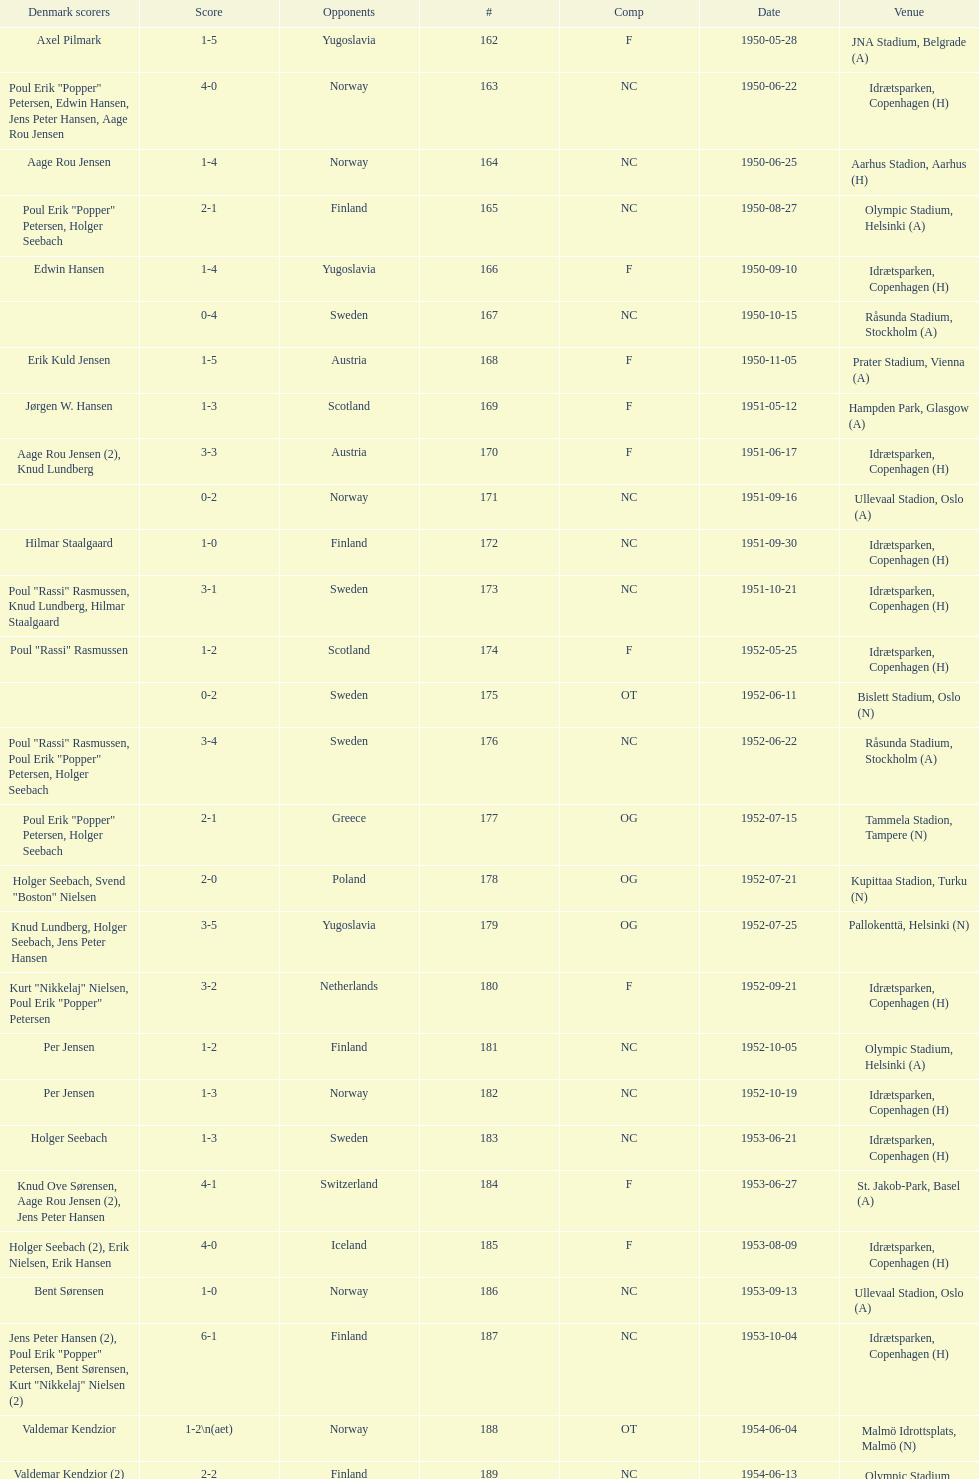Can you identify the venue located immediately below jna stadium, belgrade (a)? Idrætsparken, Copenhagen (H). Would you be able to parse every entry in this table? {'header': ['Denmark scorers', 'Score', 'Opponents', '#', 'Comp', 'Date', 'Venue'], 'rows': [['Axel Pilmark', '1-5', 'Yugoslavia', '162', 'F', '1950-05-28', 'JNA Stadium, Belgrade (A)'], ['Poul Erik "Popper" Petersen, Edwin Hansen, Jens Peter Hansen, Aage Rou Jensen', '4-0', 'Norway', '163', 'NC', '1950-06-22', 'Idrætsparken, Copenhagen (H)'], ['Aage Rou Jensen', '1-4', 'Norway', '164', 'NC', '1950-06-25', 'Aarhus Stadion, Aarhus (H)'], ['Poul Erik "Popper" Petersen, Holger Seebach', '2-1', 'Finland', '165', 'NC', '1950-08-27', 'Olympic Stadium, Helsinki (A)'], ['Edwin Hansen', '1-4', 'Yugoslavia', '166', 'F', '1950-09-10', 'Idrætsparken, Copenhagen (H)'], ['', '0-4', 'Sweden', '167', 'NC', '1950-10-15', 'Råsunda Stadium, Stockholm (A)'], ['Erik Kuld Jensen', '1-5', 'Austria', '168', 'F', '1950-11-05', 'Prater Stadium, Vienna (A)'], ['Jørgen W. Hansen', '1-3', 'Scotland', '169', 'F', '1951-05-12', 'Hampden Park, Glasgow (A)'], ['Aage Rou Jensen (2), Knud Lundberg', '3-3', 'Austria', '170', 'F', '1951-06-17', 'Idrætsparken, Copenhagen (H)'], ['', '0-2', 'Norway', '171', 'NC', '1951-09-16', 'Ullevaal Stadion, Oslo (A)'], ['Hilmar Staalgaard', '1-0', 'Finland', '172', 'NC', '1951-09-30', 'Idrætsparken, Copenhagen (H)'], ['Poul "Rassi" Rasmussen, Knud Lundberg, Hilmar Staalgaard', '3-1', 'Sweden', '173', 'NC', '1951-10-21', 'Idrætsparken, Copenhagen (H)'], ['Poul "Rassi" Rasmussen', '1-2', 'Scotland', '174', 'F', '1952-05-25', 'Idrætsparken, Copenhagen (H)'], ['', '0-2', 'Sweden', '175', 'OT', '1952-06-11', 'Bislett Stadium, Oslo (N)'], ['Poul "Rassi" Rasmussen, Poul Erik "Popper" Petersen, Holger Seebach', '3-4', 'Sweden', '176', 'NC', '1952-06-22', 'Råsunda Stadium, Stockholm (A)'], ['Poul Erik "Popper" Petersen, Holger Seebach', '2-1', 'Greece', '177', 'OG', '1952-07-15', 'Tammela Stadion, Tampere (N)'], ['Holger Seebach, Svend "Boston" Nielsen', '2-0', 'Poland', '178', 'OG', '1952-07-21', 'Kupittaa Stadion, Turku (N)'], ['Knud Lundberg, Holger Seebach, Jens Peter Hansen', '3-5', 'Yugoslavia', '179', 'OG', '1952-07-25', 'Pallokenttä, Helsinki (N)'], ['Kurt "Nikkelaj" Nielsen, Poul Erik "Popper" Petersen', '3-2', 'Netherlands', '180', 'F', '1952-09-21', 'Idrætsparken, Copenhagen (H)'], ['Per Jensen', '1-2', 'Finland', '181', 'NC', '1952-10-05', 'Olympic Stadium, Helsinki (A)'], ['Per Jensen', '1-3', 'Norway', '182', 'NC', '1952-10-19', 'Idrætsparken, Copenhagen (H)'], ['Holger Seebach', '1-3', 'Sweden', '183', 'NC', '1953-06-21', 'Idrætsparken, Copenhagen (H)'], ['Knud Ove Sørensen, Aage Rou Jensen (2), Jens Peter Hansen', '4-1', 'Switzerland', '184', 'F', '1953-06-27', 'St. Jakob-Park, Basel (A)'], ['Holger Seebach (2), Erik Nielsen, Erik Hansen', '4-0', 'Iceland', '185', 'F', '1953-08-09', 'Idrætsparken, Copenhagen (H)'], ['Bent Sørensen', '1-0', 'Norway', '186', 'NC', '1953-09-13', 'Ullevaal Stadion, Oslo (A)'], ['Jens Peter Hansen (2), Poul Erik "Popper" Petersen, Bent Sørensen, Kurt "Nikkelaj" Nielsen (2)', '6-1', 'Finland', '187', 'NC', '1953-10-04', 'Idrætsparken, Copenhagen (H)'], ['Valdemar Kendzior', '1-2\\n(aet)', 'Norway', '188', 'OT', '1954-06-04', 'Malmö Idrottsplats, Malmö (N)'], ['Valdemar Kendzior (2)', '2-2', 'Finland', '189', 'NC', '1954-06-13', 'Olympic Stadium, Helsinki (A)'], ['Jørgen Olesen', '1-1', 'Switzerland', '190', 'F', '1954-09-19', 'Idrætsparken, Copenhagen (H)'], ['Jens Peter Hansen, Bent Sørensen', '2-5', 'Sweden', '191', 'NC', '1954-10-10', 'Råsunda Stadium, Stockholm (A)'], ['', '0-1', 'Norway', '192', 'NC', '1954-10-31', 'Idrætsparken, Copenhagen (H)'], ['Vagn Birkeland', '1-1', 'Netherlands', '193', 'F', '1955-03-13', 'Olympic Stadium, Amsterdam (A)'], ['', '0-6', 'Hungary', '194', 'F', '1955-05-15', 'Idrætsparken, Copenhagen (H)'], ['Jens Peter Hansen (2)', '2-1', 'Finland', '195', 'NC', '1955-06-19', 'Idrætsparken, Copenhagen (H)'], ['Aage Rou Jensen, Jens Peter Hansen, Poul Pedersen (2)', '4-0', 'Iceland', '196', 'F', '1955-06-03', 'Melavollur, Reykjavík (A)'], ['Jørgen Jacobsen', '1-1', 'Norway', '197', 'NC', '1955-09-11', 'Ullevaal Stadion, Oslo (A)'], ['Knud Lundberg', '1-5', 'England', '198', 'NC', '1955-10-02', 'Idrætsparken, Copenhagen (H)'], ['Ove Andersen (2), Knud Lundberg', '3-3', 'Sweden', '199', 'NC', '1955-10-16', 'Idrætsparken, Copenhagen (H)'], ['Knud Lundberg', '1-5', 'USSR', '200', 'F', '1956-05-23', 'Dynamo Stadium, Moscow (A)'], ['Knud Lundberg, Poul Pedersen', '2-3', 'Norway', '201', 'NC', '1956-06-24', 'Idrætsparken, Copenhagen (H)'], ['Ove Andersen, Aage Rou Jensen', '2-5', 'USSR', '202', 'F', '1956-07-01', 'Idrætsparken, Copenhagen (H)'], ['Poul Pedersen, Jørgen Hansen, Ove Andersen (2)', '4-0', 'Finland', '203', 'NC', '1956-09-16', 'Olympic Stadium, Helsinki (A)'], ['Aage Rou Jensen', '1-2', 'Republic of Ireland', '204', 'WCQ', '1956-10-03', 'Dalymount Park, Dublin (A)'], ['Jens Peter Hansen', '1-1', 'Sweden', '205', 'NC', '1956-10-21', 'Råsunda Stadium, Stockholm (A)'], ['Jørgen Olesen, Knud Lundberg', '2-2', 'Netherlands', '206', 'F', '1956-11-04', 'Idrætsparken, Copenhagen (H)'], ['Ove Bech Nielsen (2)', '2-5', 'England', '207', 'WCQ', '1956-12-05', 'Molineux, Wolverhampton (A)'], ['John Jensen', '1-4', 'England', '208', 'WCQ', '1957-05-15', 'Idrætsparken, Copenhagen (H)'], ['Aage Rou Jensen', '1-1', 'Bulgaria', '209', 'F', '1957-05-26', 'Idrætsparken, Copenhagen (H)'], ['', '0-2', 'Finland', '210', 'OT', '1957-06-18', 'Olympic Stadium, Helsinki (A)'], ['Egon Jensen, Jørgen Hansen', '2-0', 'Norway', '211', 'OT', '1957-06-19', 'Tammela Stadion, Tampere (N)'], ['Jens Peter Hansen', '1-2', 'Sweden', '212', 'NC', '1957-06-30', 'Idrætsparken, Copenhagen (H)'], ['Egon Jensen (3), Poul Pedersen, Jens Peter Hansen (2)', '6-2', 'Iceland', '213', 'OT', '1957-07-10', 'Laugardalsvöllur, Reykjavík (A)'], ['Poul Pedersen, Peder Kjær', '2-2', 'Norway', '214', 'NC', '1957-09-22', 'Ullevaal Stadion, Oslo (A)'], ['', '0-2', 'Republic of Ireland', '215', 'WCQ', '1957-10-02', 'Idrætsparken, Copenhagen (H)'], ['Finn Alfred Hansen, Ove Bech Nielsen, Mogens Machon', '3-0', 'Finland', '216', 'NC', '1957-10-13', 'Idrætsparken, Copenhagen (H)'], ['Poul Pedersen, Henning Enoksen (2)', '3-2', 'Curaçao', '217', 'F', '1958-05-15', 'Aarhus Stadion, Aarhus (H)'], ['Jørn Sørensen, Poul Pedersen (2)', '3-2', 'Poland', '218', 'F', '1958-05-25', 'Idrætsparken, Copenhagen (H)'], ['Poul Pedersen', '1-2', 'Norway', '219', 'NC', '1958-06-29', 'Idrætsparken, Copenhagen (H)'], ['Poul Pedersen, Mogens Machon, John Danielsen (2)', '4-1', 'Finland', '220', 'NC', '1958-09-14', 'Olympic Stadium, Helsinki (A)'], ['Henning Enoksen', '1-1', 'West Germany', '221', 'F', '1958-09-24', 'Idrætsparken, Copenhagen (H)'], ['Henning Enoksen', '1-5', 'Netherlands', '222', 'F', '1958-10-15', 'Idrætsparken, Copenhagen (H)'], ['Ole Madsen (2), Henning Enoksen, Jørn Sørensen', '4-4', 'Sweden', '223', 'NC', '1958-10-26', 'Råsunda Stadium, Stockholm (A)'], ['', '0-6', 'Sweden', '224', 'NC', '1959-06-21', 'Idrætsparken, Copenhagen (H)'], ['Jens Peter Hansen (2), Ole Madsen (2)', '4-2', 'Iceland', '225', 'OGQ', '1959-06-26', 'Laugardalsvöllur, Reykjavík (A)'], ['Henning Enoksen, Ole Madsen', '2-1', 'Norway', '226', 'OGQ', '1959-07-02', 'Idrætsparken, Copenhagen (H)'], ['Henning Enoksen', '1-1', 'Iceland', '227', 'OGQ', '1959-08-18', 'Idrætsparken, Copenhagen (H)'], ['Harald Nielsen, Henning Enoksen (2), Poul Pedersen', '4-2', 'Norway', '228', 'OGQ\\nNC', '1959-09-13', 'Ullevaal Stadion, Oslo (A)'], ['Poul Pedersen, Bent Hansen', '2-2', 'Czechoslovakia', '229', 'ENQ', '1959-09-23', 'Idrætsparken, Copenhagen (H)'], ['Harald Nielsen (3), John Kramer', '4-0', 'Finland', '230', 'NC', '1959-10-04', 'Idrætsparken, Copenhagen (H)'], ['John Kramer', '1-5', 'Czechoslovakia', '231', 'ENQ', '1959-10-18', 'Stadion Za Lužánkami, Brno (A)'], ['Henning Enoksen (2), Poul Pedersen', '3-1', 'Greece', '232', 'F', '1959-12-02', 'Olympic Stadium, Athens (A)'], ['Henning Enoksen', '1-2', 'Bulgaria', '233', 'F', '1959-12-06', 'Vasil Levski National Stadium, Sofia (A)']]} 